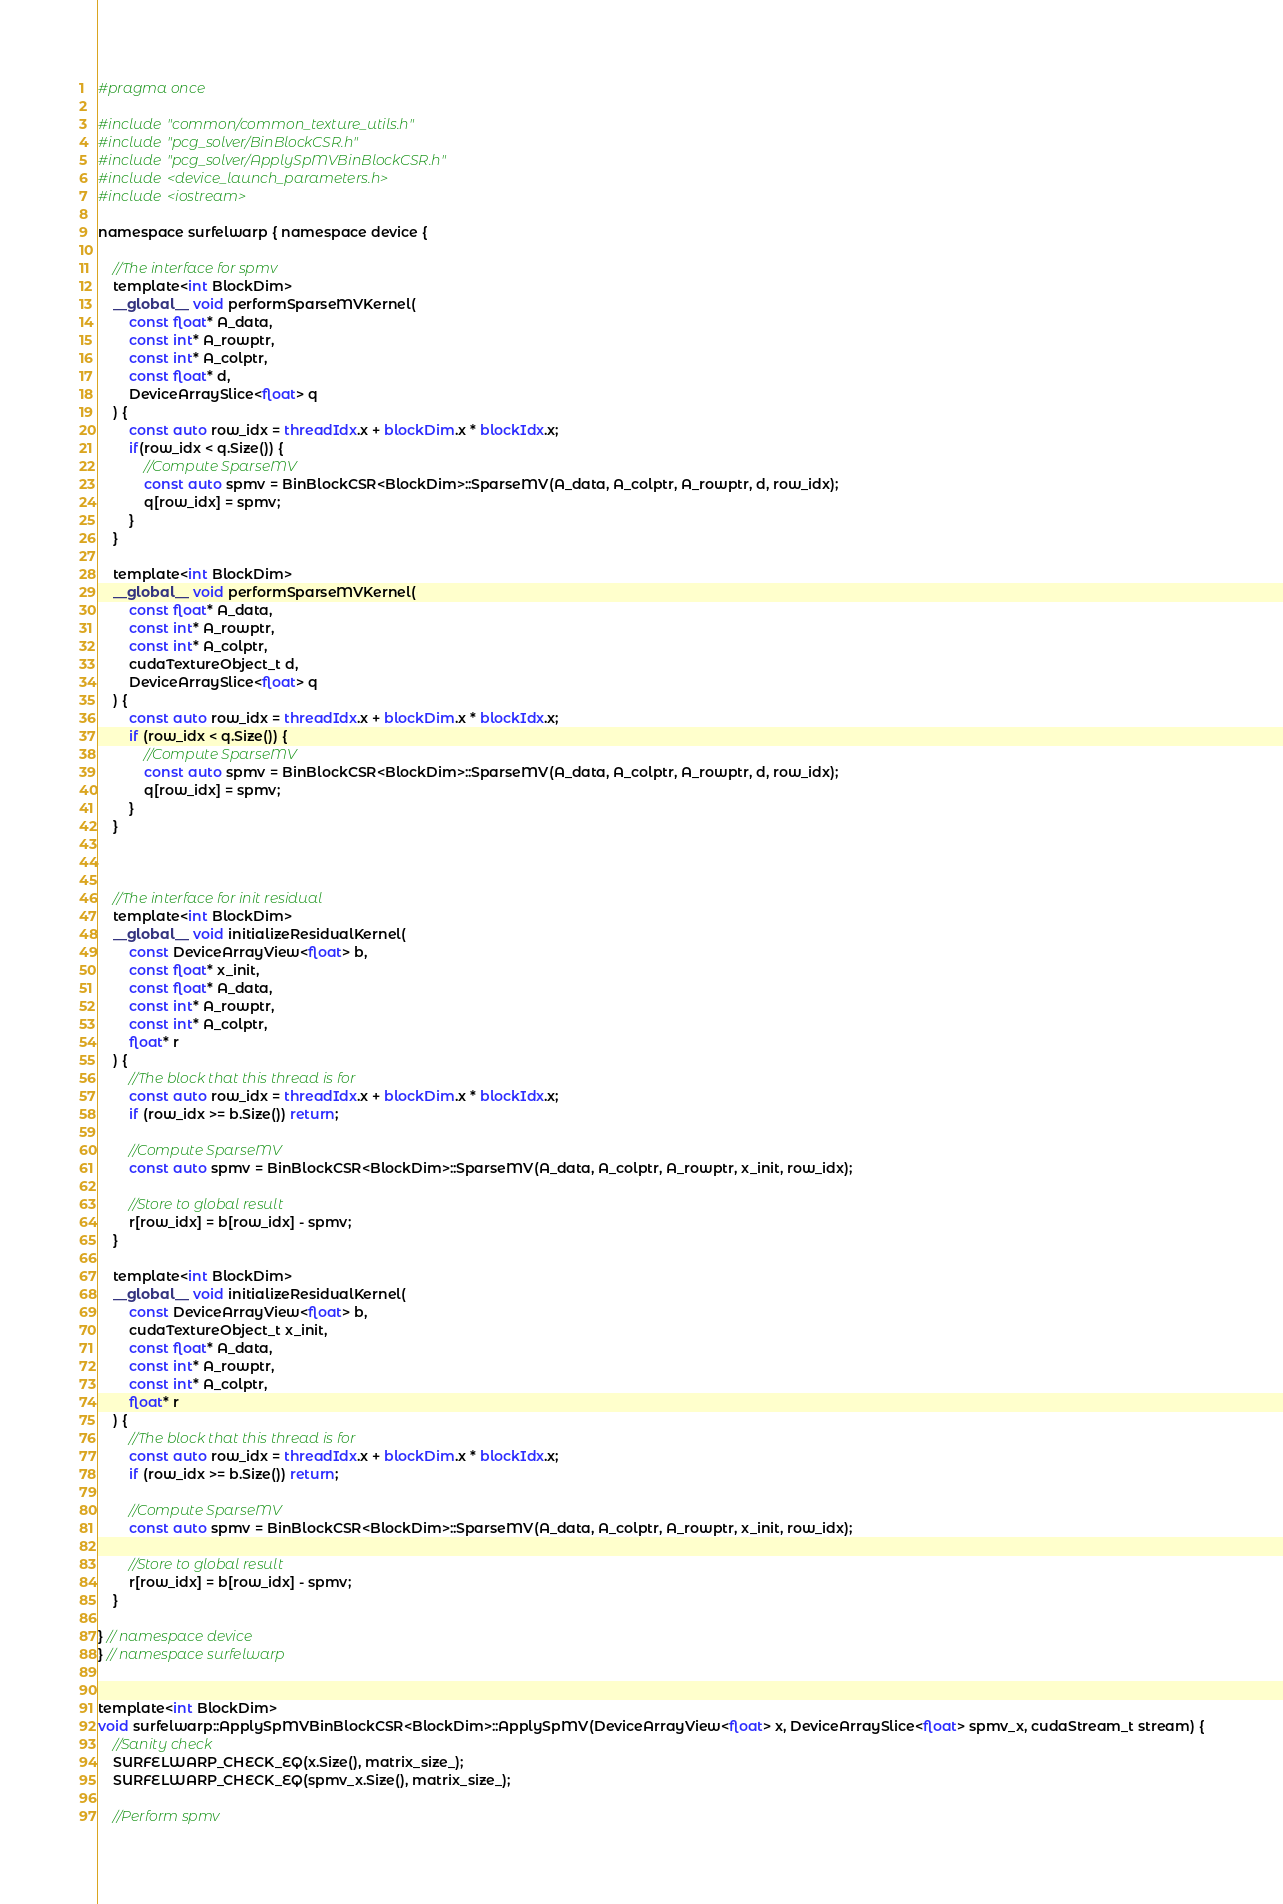Convert code to text. <code><loc_0><loc_0><loc_500><loc_500><_Cuda_>#pragma once

#include "common/common_texture_utils.h"
#include "pcg_solver/BinBlockCSR.h"
#include "pcg_solver/ApplySpMVBinBlockCSR.h"
#include <device_launch_parameters.h>
#include <iostream>

namespace surfelwarp { namespace device {
	
	//The interface for spmv
	template<int BlockDim>
	__global__ void performSparseMVKernel(
		const float* A_data,
		const int* A_rowptr,
		const int* A_colptr,
		const float* d,
		DeviceArraySlice<float> q
	) {
		const auto row_idx = threadIdx.x + blockDim.x * blockIdx.x;
		if(row_idx < q.Size()) {
			//Compute SparseMV
			const auto spmv = BinBlockCSR<BlockDim>::SparseMV(A_data, A_colptr, A_rowptr, d, row_idx);
			q[row_idx] = spmv;
		}
	}

	template<int BlockDim>
	__global__ void performSparseMVKernel(
		const float* A_data,
		const int* A_rowptr,
		const int* A_colptr,
		cudaTextureObject_t d,
		DeviceArraySlice<float> q
	) {
		const auto row_idx = threadIdx.x + blockDim.x * blockIdx.x;
		if (row_idx < q.Size()) {
			//Compute SparseMV
			const auto spmv = BinBlockCSR<BlockDim>::SparseMV(A_data, A_colptr, A_rowptr, d, row_idx);
			q[row_idx] = spmv;
		}
	}



	//The interface for init residual
	template<int BlockDim>
	__global__ void initializeResidualKernel(
		const DeviceArrayView<float> b,
		const float* x_init,
		const float* A_data,
		const int* A_rowptr,
		const int* A_colptr,
		float* r
	) {
		//The block that this thread is for
		const auto row_idx = threadIdx.x + blockDim.x * blockIdx.x;
		if (row_idx >= b.Size()) return;

		//Compute SparseMV
		const auto spmv = BinBlockCSR<BlockDim>::SparseMV(A_data, A_colptr, A_rowptr, x_init, row_idx);

		//Store to global result
		r[row_idx] = b[row_idx] - spmv;
	}

	template<int BlockDim>
    __global__ void initializeResidualKernel(
        const DeviceArrayView<float> b,
        cudaTextureObject_t x_init,
        const float* A_data,
		const int* A_rowptr,
		const int* A_colptr,
        float* r
    ) {
        //The block that this thread is for
        const auto row_idx = threadIdx.x + blockDim.x * blockIdx.x;
        if (row_idx >= b.Size()) return;

        //Compute SparseMV
        const auto spmv = BinBlockCSR<BlockDim>::SparseMV(A_data, A_colptr, A_rowptr, x_init, row_idx);

        //Store to global result
        r[row_idx] = b[row_idx] - spmv;
    }

} // namespace device
} // namespace surfelwarp


template<int BlockDim>
void surfelwarp::ApplySpMVBinBlockCSR<BlockDim>::ApplySpMV(DeviceArrayView<float> x, DeviceArraySlice<float> spmv_x, cudaStream_t stream) {
	//Sanity check
	SURFELWARP_CHECK_EQ(x.Size(), matrix_size_);
	SURFELWARP_CHECK_EQ(spmv_x.Size(), matrix_size_);

	//Perform spmv</code> 